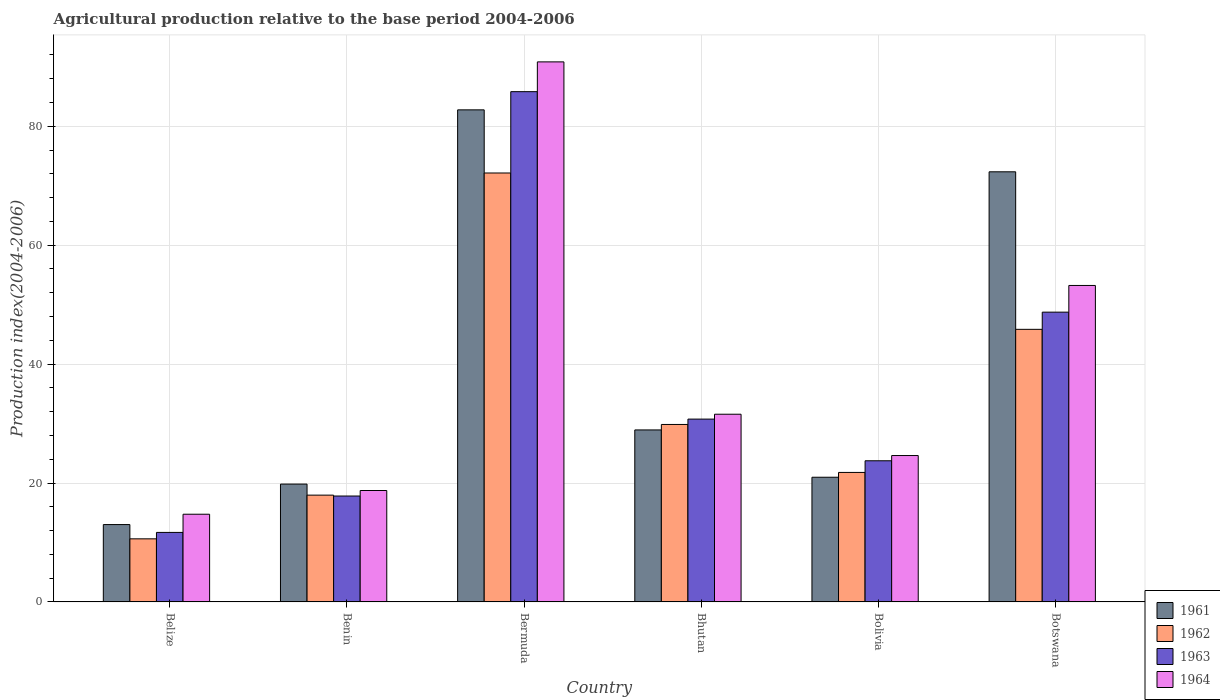Are the number of bars on each tick of the X-axis equal?
Provide a succinct answer. Yes. How many bars are there on the 6th tick from the left?
Give a very brief answer. 4. What is the label of the 2nd group of bars from the left?
Your response must be concise. Benin. What is the agricultural production index in 1963 in Belize?
Ensure brevity in your answer.  11.69. Across all countries, what is the maximum agricultural production index in 1962?
Your answer should be compact. 72.15. Across all countries, what is the minimum agricultural production index in 1964?
Provide a short and direct response. 14.75. In which country was the agricultural production index in 1962 maximum?
Give a very brief answer. Bermuda. In which country was the agricultural production index in 1963 minimum?
Give a very brief answer. Belize. What is the total agricultural production index in 1964 in the graph?
Give a very brief answer. 233.75. What is the difference between the agricultural production index in 1962 in Bermuda and that in Bhutan?
Offer a very short reply. 42.3. What is the difference between the agricultural production index in 1963 in Belize and the agricultural production index in 1961 in Botswana?
Ensure brevity in your answer.  -60.66. What is the average agricultural production index in 1962 per country?
Make the answer very short. 33.03. What is the difference between the agricultural production index of/in 1962 and agricultural production index of/in 1963 in Bermuda?
Your answer should be very brief. -13.68. In how many countries, is the agricultural production index in 1964 greater than 52?
Ensure brevity in your answer.  2. What is the ratio of the agricultural production index in 1963 in Benin to that in Bhutan?
Your answer should be compact. 0.58. Is the agricultural production index in 1962 in Benin less than that in Botswana?
Your answer should be compact. Yes. What is the difference between the highest and the second highest agricultural production index in 1961?
Give a very brief answer. -10.42. What is the difference between the highest and the lowest agricultural production index in 1961?
Offer a terse response. 69.76. In how many countries, is the agricultural production index in 1963 greater than the average agricultural production index in 1963 taken over all countries?
Ensure brevity in your answer.  2. Is it the case that in every country, the sum of the agricultural production index in 1962 and agricultural production index in 1964 is greater than the sum of agricultural production index in 1961 and agricultural production index in 1963?
Your answer should be compact. No. What does the 3rd bar from the left in Bolivia represents?
Make the answer very short. 1963. Are all the bars in the graph horizontal?
Provide a succinct answer. No. Does the graph contain any zero values?
Ensure brevity in your answer.  No. Where does the legend appear in the graph?
Offer a very short reply. Bottom right. How many legend labels are there?
Provide a short and direct response. 4. How are the legend labels stacked?
Your answer should be compact. Vertical. What is the title of the graph?
Make the answer very short. Agricultural production relative to the base period 2004-2006. Does "1989" appear as one of the legend labels in the graph?
Your answer should be compact. No. What is the label or title of the Y-axis?
Give a very brief answer. Production index(2004-2006). What is the Production index(2004-2006) of 1961 in Belize?
Your answer should be very brief. 13.01. What is the Production index(2004-2006) of 1962 in Belize?
Offer a terse response. 10.61. What is the Production index(2004-2006) in 1963 in Belize?
Ensure brevity in your answer.  11.69. What is the Production index(2004-2006) of 1964 in Belize?
Make the answer very short. 14.75. What is the Production index(2004-2006) of 1961 in Benin?
Give a very brief answer. 19.82. What is the Production index(2004-2006) of 1962 in Benin?
Offer a very short reply. 17.96. What is the Production index(2004-2006) of 1963 in Benin?
Make the answer very short. 17.81. What is the Production index(2004-2006) of 1964 in Benin?
Your answer should be very brief. 18.74. What is the Production index(2004-2006) of 1961 in Bermuda?
Provide a succinct answer. 82.77. What is the Production index(2004-2006) in 1962 in Bermuda?
Give a very brief answer. 72.15. What is the Production index(2004-2006) of 1963 in Bermuda?
Your answer should be compact. 85.83. What is the Production index(2004-2006) in 1964 in Bermuda?
Keep it short and to the point. 90.84. What is the Production index(2004-2006) of 1961 in Bhutan?
Provide a short and direct response. 28.93. What is the Production index(2004-2006) in 1962 in Bhutan?
Offer a terse response. 29.85. What is the Production index(2004-2006) of 1963 in Bhutan?
Offer a terse response. 30.75. What is the Production index(2004-2006) of 1964 in Bhutan?
Offer a terse response. 31.57. What is the Production index(2004-2006) of 1961 in Bolivia?
Keep it short and to the point. 20.97. What is the Production index(2004-2006) of 1962 in Bolivia?
Your answer should be compact. 21.78. What is the Production index(2004-2006) of 1963 in Bolivia?
Provide a succinct answer. 23.74. What is the Production index(2004-2006) of 1964 in Bolivia?
Ensure brevity in your answer.  24.62. What is the Production index(2004-2006) in 1961 in Botswana?
Provide a succinct answer. 72.35. What is the Production index(2004-2006) in 1962 in Botswana?
Offer a terse response. 45.85. What is the Production index(2004-2006) of 1963 in Botswana?
Your answer should be compact. 48.74. What is the Production index(2004-2006) of 1964 in Botswana?
Your answer should be very brief. 53.23. Across all countries, what is the maximum Production index(2004-2006) in 1961?
Ensure brevity in your answer.  82.77. Across all countries, what is the maximum Production index(2004-2006) in 1962?
Give a very brief answer. 72.15. Across all countries, what is the maximum Production index(2004-2006) of 1963?
Make the answer very short. 85.83. Across all countries, what is the maximum Production index(2004-2006) of 1964?
Give a very brief answer. 90.84. Across all countries, what is the minimum Production index(2004-2006) of 1961?
Your response must be concise. 13.01. Across all countries, what is the minimum Production index(2004-2006) of 1962?
Your answer should be compact. 10.61. Across all countries, what is the minimum Production index(2004-2006) of 1963?
Offer a terse response. 11.69. Across all countries, what is the minimum Production index(2004-2006) in 1964?
Provide a succinct answer. 14.75. What is the total Production index(2004-2006) in 1961 in the graph?
Offer a terse response. 237.85. What is the total Production index(2004-2006) of 1962 in the graph?
Your response must be concise. 198.2. What is the total Production index(2004-2006) in 1963 in the graph?
Give a very brief answer. 218.56. What is the total Production index(2004-2006) in 1964 in the graph?
Make the answer very short. 233.75. What is the difference between the Production index(2004-2006) of 1961 in Belize and that in Benin?
Ensure brevity in your answer.  -6.81. What is the difference between the Production index(2004-2006) in 1962 in Belize and that in Benin?
Ensure brevity in your answer.  -7.35. What is the difference between the Production index(2004-2006) in 1963 in Belize and that in Benin?
Give a very brief answer. -6.12. What is the difference between the Production index(2004-2006) in 1964 in Belize and that in Benin?
Offer a terse response. -3.99. What is the difference between the Production index(2004-2006) of 1961 in Belize and that in Bermuda?
Give a very brief answer. -69.76. What is the difference between the Production index(2004-2006) of 1962 in Belize and that in Bermuda?
Ensure brevity in your answer.  -61.54. What is the difference between the Production index(2004-2006) in 1963 in Belize and that in Bermuda?
Ensure brevity in your answer.  -74.14. What is the difference between the Production index(2004-2006) of 1964 in Belize and that in Bermuda?
Your answer should be very brief. -76.09. What is the difference between the Production index(2004-2006) in 1961 in Belize and that in Bhutan?
Your answer should be compact. -15.92. What is the difference between the Production index(2004-2006) of 1962 in Belize and that in Bhutan?
Give a very brief answer. -19.24. What is the difference between the Production index(2004-2006) of 1963 in Belize and that in Bhutan?
Provide a short and direct response. -19.06. What is the difference between the Production index(2004-2006) of 1964 in Belize and that in Bhutan?
Your response must be concise. -16.82. What is the difference between the Production index(2004-2006) of 1961 in Belize and that in Bolivia?
Keep it short and to the point. -7.96. What is the difference between the Production index(2004-2006) of 1962 in Belize and that in Bolivia?
Offer a terse response. -11.17. What is the difference between the Production index(2004-2006) in 1963 in Belize and that in Bolivia?
Ensure brevity in your answer.  -12.05. What is the difference between the Production index(2004-2006) in 1964 in Belize and that in Bolivia?
Your response must be concise. -9.87. What is the difference between the Production index(2004-2006) in 1961 in Belize and that in Botswana?
Offer a very short reply. -59.34. What is the difference between the Production index(2004-2006) of 1962 in Belize and that in Botswana?
Provide a succinct answer. -35.24. What is the difference between the Production index(2004-2006) of 1963 in Belize and that in Botswana?
Ensure brevity in your answer.  -37.05. What is the difference between the Production index(2004-2006) of 1964 in Belize and that in Botswana?
Provide a succinct answer. -38.48. What is the difference between the Production index(2004-2006) in 1961 in Benin and that in Bermuda?
Ensure brevity in your answer.  -62.95. What is the difference between the Production index(2004-2006) of 1962 in Benin and that in Bermuda?
Make the answer very short. -54.19. What is the difference between the Production index(2004-2006) of 1963 in Benin and that in Bermuda?
Give a very brief answer. -68.02. What is the difference between the Production index(2004-2006) in 1964 in Benin and that in Bermuda?
Your response must be concise. -72.1. What is the difference between the Production index(2004-2006) in 1961 in Benin and that in Bhutan?
Offer a terse response. -9.11. What is the difference between the Production index(2004-2006) in 1962 in Benin and that in Bhutan?
Ensure brevity in your answer.  -11.89. What is the difference between the Production index(2004-2006) in 1963 in Benin and that in Bhutan?
Ensure brevity in your answer.  -12.94. What is the difference between the Production index(2004-2006) in 1964 in Benin and that in Bhutan?
Provide a succinct answer. -12.83. What is the difference between the Production index(2004-2006) in 1961 in Benin and that in Bolivia?
Provide a succinct answer. -1.15. What is the difference between the Production index(2004-2006) in 1962 in Benin and that in Bolivia?
Provide a succinct answer. -3.82. What is the difference between the Production index(2004-2006) in 1963 in Benin and that in Bolivia?
Keep it short and to the point. -5.93. What is the difference between the Production index(2004-2006) of 1964 in Benin and that in Bolivia?
Offer a terse response. -5.88. What is the difference between the Production index(2004-2006) in 1961 in Benin and that in Botswana?
Make the answer very short. -52.53. What is the difference between the Production index(2004-2006) of 1962 in Benin and that in Botswana?
Your answer should be very brief. -27.89. What is the difference between the Production index(2004-2006) of 1963 in Benin and that in Botswana?
Provide a succinct answer. -30.93. What is the difference between the Production index(2004-2006) of 1964 in Benin and that in Botswana?
Offer a very short reply. -34.49. What is the difference between the Production index(2004-2006) of 1961 in Bermuda and that in Bhutan?
Offer a very short reply. 53.84. What is the difference between the Production index(2004-2006) of 1962 in Bermuda and that in Bhutan?
Your response must be concise. 42.3. What is the difference between the Production index(2004-2006) in 1963 in Bermuda and that in Bhutan?
Your response must be concise. 55.08. What is the difference between the Production index(2004-2006) in 1964 in Bermuda and that in Bhutan?
Ensure brevity in your answer.  59.27. What is the difference between the Production index(2004-2006) of 1961 in Bermuda and that in Bolivia?
Provide a succinct answer. 61.8. What is the difference between the Production index(2004-2006) of 1962 in Bermuda and that in Bolivia?
Provide a succinct answer. 50.37. What is the difference between the Production index(2004-2006) in 1963 in Bermuda and that in Bolivia?
Offer a terse response. 62.09. What is the difference between the Production index(2004-2006) of 1964 in Bermuda and that in Bolivia?
Provide a short and direct response. 66.22. What is the difference between the Production index(2004-2006) in 1961 in Bermuda and that in Botswana?
Your answer should be very brief. 10.42. What is the difference between the Production index(2004-2006) in 1962 in Bermuda and that in Botswana?
Your response must be concise. 26.3. What is the difference between the Production index(2004-2006) in 1963 in Bermuda and that in Botswana?
Offer a terse response. 37.09. What is the difference between the Production index(2004-2006) in 1964 in Bermuda and that in Botswana?
Offer a terse response. 37.61. What is the difference between the Production index(2004-2006) of 1961 in Bhutan and that in Bolivia?
Provide a short and direct response. 7.96. What is the difference between the Production index(2004-2006) in 1962 in Bhutan and that in Bolivia?
Ensure brevity in your answer.  8.07. What is the difference between the Production index(2004-2006) of 1963 in Bhutan and that in Bolivia?
Give a very brief answer. 7.01. What is the difference between the Production index(2004-2006) of 1964 in Bhutan and that in Bolivia?
Provide a short and direct response. 6.95. What is the difference between the Production index(2004-2006) of 1961 in Bhutan and that in Botswana?
Your response must be concise. -43.42. What is the difference between the Production index(2004-2006) in 1963 in Bhutan and that in Botswana?
Give a very brief answer. -17.99. What is the difference between the Production index(2004-2006) of 1964 in Bhutan and that in Botswana?
Your answer should be very brief. -21.66. What is the difference between the Production index(2004-2006) in 1961 in Bolivia and that in Botswana?
Your answer should be very brief. -51.38. What is the difference between the Production index(2004-2006) in 1962 in Bolivia and that in Botswana?
Make the answer very short. -24.07. What is the difference between the Production index(2004-2006) in 1963 in Bolivia and that in Botswana?
Keep it short and to the point. -25. What is the difference between the Production index(2004-2006) in 1964 in Bolivia and that in Botswana?
Make the answer very short. -28.61. What is the difference between the Production index(2004-2006) of 1961 in Belize and the Production index(2004-2006) of 1962 in Benin?
Your answer should be compact. -4.95. What is the difference between the Production index(2004-2006) of 1961 in Belize and the Production index(2004-2006) of 1963 in Benin?
Your answer should be compact. -4.8. What is the difference between the Production index(2004-2006) in 1961 in Belize and the Production index(2004-2006) in 1964 in Benin?
Your answer should be very brief. -5.73. What is the difference between the Production index(2004-2006) in 1962 in Belize and the Production index(2004-2006) in 1963 in Benin?
Your answer should be compact. -7.2. What is the difference between the Production index(2004-2006) in 1962 in Belize and the Production index(2004-2006) in 1964 in Benin?
Keep it short and to the point. -8.13. What is the difference between the Production index(2004-2006) of 1963 in Belize and the Production index(2004-2006) of 1964 in Benin?
Provide a short and direct response. -7.05. What is the difference between the Production index(2004-2006) in 1961 in Belize and the Production index(2004-2006) in 1962 in Bermuda?
Your response must be concise. -59.14. What is the difference between the Production index(2004-2006) of 1961 in Belize and the Production index(2004-2006) of 1963 in Bermuda?
Provide a short and direct response. -72.82. What is the difference between the Production index(2004-2006) of 1961 in Belize and the Production index(2004-2006) of 1964 in Bermuda?
Offer a very short reply. -77.83. What is the difference between the Production index(2004-2006) of 1962 in Belize and the Production index(2004-2006) of 1963 in Bermuda?
Give a very brief answer. -75.22. What is the difference between the Production index(2004-2006) in 1962 in Belize and the Production index(2004-2006) in 1964 in Bermuda?
Offer a very short reply. -80.23. What is the difference between the Production index(2004-2006) in 1963 in Belize and the Production index(2004-2006) in 1964 in Bermuda?
Your answer should be compact. -79.15. What is the difference between the Production index(2004-2006) of 1961 in Belize and the Production index(2004-2006) of 1962 in Bhutan?
Make the answer very short. -16.84. What is the difference between the Production index(2004-2006) in 1961 in Belize and the Production index(2004-2006) in 1963 in Bhutan?
Make the answer very short. -17.74. What is the difference between the Production index(2004-2006) of 1961 in Belize and the Production index(2004-2006) of 1964 in Bhutan?
Your response must be concise. -18.56. What is the difference between the Production index(2004-2006) in 1962 in Belize and the Production index(2004-2006) in 1963 in Bhutan?
Offer a terse response. -20.14. What is the difference between the Production index(2004-2006) in 1962 in Belize and the Production index(2004-2006) in 1964 in Bhutan?
Ensure brevity in your answer.  -20.96. What is the difference between the Production index(2004-2006) of 1963 in Belize and the Production index(2004-2006) of 1964 in Bhutan?
Your response must be concise. -19.88. What is the difference between the Production index(2004-2006) in 1961 in Belize and the Production index(2004-2006) in 1962 in Bolivia?
Offer a terse response. -8.77. What is the difference between the Production index(2004-2006) in 1961 in Belize and the Production index(2004-2006) in 1963 in Bolivia?
Make the answer very short. -10.73. What is the difference between the Production index(2004-2006) of 1961 in Belize and the Production index(2004-2006) of 1964 in Bolivia?
Give a very brief answer. -11.61. What is the difference between the Production index(2004-2006) in 1962 in Belize and the Production index(2004-2006) in 1963 in Bolivia?
Your answer should be very brief. -13.13. What is the difference between the Production index(2004-2006) of 1962 in Belize and the Production index(2004-2006) of 1964 in Bolivia?
Make the answer very short. -14.01. What is the difference between the Production index(2004-2006) in 1963 in Belize and the Production index(2004-2006) in 1964 in Bolivia?
Provide a short and direct response. -12.93. What is the difference between the Production index(2004-2006) of 1961 in Belize and the Production index(2004-2006) of 1962 in Botswana?
Ensure brevity in your answer.  -32.84. What is the difference between the Production index(2004-2006) of 1961 in Belize and the Production index(2004-2006) of 1963 in Botswana?
Ensure brevity in your answer.  -35.73. What is the difference between the Production index(2004-2006) in 1961 in Belize and the Production index(2004-2006) in 1964 in Botswana?
Offer a very short reply. -40.22. What is the difference between the Production index(2004-2006) of 1962 in Belize and the Production index(2004-2006) of 1963 in Botswana?
Keep it short and to the point. -38.13. What is the difference between the Production index(2004-2006) of 1962 in Belize and the Production index(2004-2006) of 1964 in Botswana?
Provide a succinct answer. -42.62. What is the difference between the Production index(2004-2006) of 1963 in Belize and the Production index(2004-2006) of 1964 in Botswana?
Keep it short and to the point. -41.54. What is the difference between the Production index(2004-2006) of 1961 in Benin and the Production index(2004-2006) of 1962 in Bermuda?
Keep it short and to the point. -52.33. What is the difference between the Production index(2004-2006) of 1961 in Benin and the Production index(2004-2006) of 1963 in Bermuda?
Keep it short and to the point. -66.01. What is the difference between the Production index(2004-2006) in 1961 in Benin and the Production index(2004-2006) in 1964 in Bermuda?
Offer a very short reply. -71.02. What is the difference between the Production index(2004-2006) of 1962 in Benin and the Production index(2004-2006) of 1963 in Bermuda?
Offer a very short reply. -67.87. What is the difference between the Production index(2004-2006) of 1962 in Benin and the Production index(2004-2006) of 1964 in Bermuda?
Provide a short and direct response. -72.88. What is the difference between the Production index(2004-2006) of 1963 in Benin and the Production index(2004-2006) of 1964 in Bermuda?
Keep it short and to the point. -73.03. What is the difference between the Production index(2004-2006) of 1961 in Benin and the Production index(2004-2006) of 1962 in Bhutan?
Ensure brevity in your answer.  -10.03. What is the difference between the Production index(2004-2006) of 1961 in Benin and the Production index(2004-2006) of 1963 in Bhutan?
Keep it short and to the point. -10.93. What is the difference between the Production index(2004-2006) of 1961 in Benin and the Production index(2004-2006) of 1964 in Bhutan?
Your answer should be compact. -11.75. What is the difference between the Production index(2004-2006) of 1962 in Benin and the Production index(2004-2006) of 1963 in Bhutan?
Give a very brief answer. -12.79. What is the difference between the Production index(2004-2006) of 1962 in Benin and the Production index(2004-2006) of 1964 in Bhutan?
Give a very brief answer. -13.61. What is the difference between the Production index(2004-2006) of 1963 in Benin and the Production index(2004-2006) of 1964 in Bhutan?
Provide a succinct answer. -13.76. What is the difference between the Production index(2004-2006) in 1961 in Benin and the Production index(2004-2006) in 1962 in Bolivia?
Your response must be concise. -1.96. What is the difference between the Production index(2004-2006) of 1961 in Benin and the Production index(2004-2006) of 1963 in Bolivia?
Provide a succinct answer. -3.92. What is the difference between the Production index(2004-2006) of 1961 in Benin and the Production index(2004-2006) of 1964 in Bolivia?
Provide a short and direct response. -4.8. What is the difference between the Production index(2004-2006) of 1962 in Benin and the Production index(2004-2006) of 1963 in Bolivia?
Provide a succinct answer. -5.78. What is the difference between the Production index(2004-2006) in 1962 in Benin and the Production index(2004-2006) in 1964 in Bolivia?
Provide a succinct answer. -6.66. What is the difference between the Production index(2004-2006) of 1963 in Benin and the Production index(2004-2006) of 1964 in Bolivia?
Make the answer very short. -6.81. What is the difference between the Production index(2004-2006) in 1961 in Benin and the Production index(2004-2006) in 1962 in Botswana?
Your answer should be very brief. -26.03. What is the difference between the Production index(2004-2006) in 1961 in Benin and the Production index(2004-2006) in 1963 in Botswana?
Make the answer very short. -28.92. What is the difference between the Production index(2004-2006) of 1961 in Benin and the Production index(2004-2006) of 1964 in Botswana?
Make the answer very short. -33.41. What is the difference between the Production index(2004-2006) in 1962 in Benin and the Production index(2004-2006) in 1963 in Botswana?
Give a very brief answer. -30.78. What is the difference between the Production index(2004-2006) of 1962 in Benin and the Production index(2004-2006) of 1964 in Botswana?
Provide a short and direct response. -35.27. What is the difference between the Production index(2004-2006) of 1963 in Benin and the Production index(2004-2006) of 1964 in Botswana?
Give a very brief answer. -35.42. What is the difference between the Production index(2004-2006) in 1961 in Bermuda and the Production index(2004-2006) in 1962 in Bhutan?
Your response must be concise. 52.92. What is the difference between the Production index(2004-2006) in 1961 in Bermuda and the Production index(2004-2006) in 1963 in Bhutan?
Your answer should be compact. 52.02. What is the difference between the Production index(2004-2006) in 1961 in Bermuda and the Production index(2004-2006) in 1964 in Bhutan?
Your answer should be compact. 51.2. What is the difference between the Production index(2004-2006) in 1962 in Bermuda and the Production index(2004-2006) in 1963 in Bhutan?
Your answer should be compact. 41.4. What is the difference between the Production index(2004-2006) of 1962 in Bermuda and the Production index(2004-2006) of 1964 in Bhutan?
Offer a very short reply. 40.58. What is the difference between the Production index(2004-2006) in 1963 in Bermuda and the Production index(2004-2006) in 1964 in Bhutan?
Keep it short and to the point. 54.26. What is the difference between the Production index(2004-2006) of 1961 in Bermuda and the Production index(2004-2006) of 1962 in Bolivia?
Make the answer very short. 60.99. What is the difference between the Production index(2004-2006) in 1961 in Bermuda and the Production index(2004-2006) in 1963 in Bolivia?
Give a very brief answer. 59.03. What is the difference between the Production index(2004-2006) of 1961 in Bermuda and the Production index(2004-2006) of 1964 in Bolivia?
Your answer should be compact. 58.15. What is the difference between the Production index(2004-2006) in 1962 in Bermuda and the Production index(2004-2006) in 1963 in Bolivia?
Give a very brief answer. 48.41. What is the difference between the Production index(2004-2006) of 1962 in Bermuda and the Production index(2004-2006) of 1964 in Bolivia?
Your response must be concise. 47.53. What is the difference between the Production index(2004-2006) of 1963 in Bermuda and the Production index(2004-2006) of 1964 in Bolivia?
Offer a very short reply. 61.21. What is the difference between the Production index(2004-2006) of 1961 in Bermuda and the Production index(2004-2006) of 1962 in Botswana?
Provide a short and direct response. 36.92. What is the difference between the Production index(2004-2006) in 1961 in Bermuda and the Production index(2004-2006) in 1963 in Botswana?
Your response must be concise. 34.03. What is the difference between the Production index(2004-2006) of 1961 in Bermuda and the Production index(2004-2006) of 1964 in Botswana?
Your answer should be very brief. 29.54. What is the difference between the Production index(2004-2006) in 1962 in Bermuda and the Production index(2004-2006) in 1963 in Botswana?
Provide a succinct answer. 23.41. What is the difference between the Production index(2004-2006) in 1962 in Bermuda and the Production index(2004-2006) in 1964 in Botswana?
Your answer should be compact. 18.92. What is the difference between the Production index(2004-2006) in 1963 in Bermuda and the Production index(2004-2006) in 1964 in Botswana?
Provide a short and direct response. 32.6. What is the difference between the Production index(2004-2006) in 1961 in Bhutan and the Production index(2004-2006) in 1962 in Bolivia?
Your answer should be compact. 7.15. What is the difference between the Production index(2004-2006) of 1961 in Bhutan and the Production index(2004-2006) of 1963 in Bolivia?
Offer a terse response. 5.19. What is the difference between the Production index(2004-2006) of 1961 in Bhutan and the Production index(2004-2006) of 1964 in Bolivia?
Keep it short and to the point. 4.31. What is the difference between the Production index(2004-2006) in 1962 in Bhutan and the Production index(2004-2006) in 1963 in Bolivia?
Make the answer very short. 6.11. What is the difference between the Production index(2004-2006) of 1962 in Bhutan and the Production index(2004-2006) of 1964 in Bolivia?
Your answer should be compact. 5.23. What is the difference between the Production index(2004-2006) of 1963 in Bhutan and the Production index(2004-2006) of 1964 in Bolivia?
Your answer should be very brief. 6.13. What is the difference between the Production index(2004-2006) of 1961 in Bhutan and the Production index(2004-2006) of 1962 in Botswana?
Give a very brief answer. -16.92. What is the difference between the Production index(2004-2006) in 1961 in Bhutan and the Production index(2004-2006) in 1963 in Botswana?
Provide a succinct answer. -19.81. What is the difference between the Production index(2004-2006) in 1961 in Bhutan and the Production index(2004-2006) in 1964 in Botswana?
Give a very brief answer. -24.3. What is the difference between the Production index(2004-2006) of 1962 in Bhutan and the Production index(2004-2006) of 1963 in Botswana?
Your answer should be compact. -18.89. What is the difference between the Production index(2004-2006) of 1962 in Bhutan and the Production index(2004-2006) of 1964 in Botswana?
Ensure brevity in your answer.  -23.38. What is the difference between the Production index(2004-2006) in 1963 in Bhutan and the Production index(2004-2006) in 1964 in Botswana?
Offer a terse response. -22.48. What is the difference between the Production index(2004-2006) in 1961 in Bolivia and the Production index(2004-2006) in 1962 in Botswana?
Your answer should be compact. -24.88. What is the difference between the Production index(2004-2006) of 1961 in Bolivia and the Production index(2004-2006) of 1963 in Botswana?
Make the answer very short. -27.77. What is the difference between the Production index(2004-2006) in 1961 in Bolivia and the Production index(2004-2006) in 1964 in Botswana?
Give a very brief answer. -32.26. What is the difference between the Production index(2004-2006) of 1962 in Bolivia and the Production index(2004-2006) of 1963 in Botswana?
Give a very brief answer. -26.96. What is the difference between the Production index(2004-2006) of 1962 in Bolivia and the Production index(2004-2006) of 1964 in Botswana?
Offer a terse response. -31.45. What is the difference between the Production index(2004-2006) in 1963 in Bolivia and the Production index(2004-2006) in 1964 in Botswana?
Give a very brief answer. -29.49. What is the average Production index(2004-2006) of 1961 per country?
Provide a succinct answer. 39.64. What is the average Production index(2004-2006) of 1962 per country?
Provide a short and direct response. 33.03. What is the average Production index(2004-2006) of 1963 per country?
Provide a short and direct response. 36.43. What is the average Production index(2004-2006) in 1964 per country?
Your answer should be compact. 38.96. What is the difference between the Production index(2004-2006) of 1961 and Production index(2004-2006) of 1963 in Belize?
Give a very brief answer. 1.32. What is the difference between the Production index(2004-2006) in 1961 and Production index(2004-2006) in 1964 in Belize?
Your response must be concise. -1.74. What is the difference between the Production index(2004-2006) of 1962 and Production index(2004-2006) of 1963 in Belize?
Your answer should be very brief. -1.08. What is the difference between the Production index(2004-2006) in 1962 and Production index(2004-2006) in 1964 in Belize?
Provide a succinct answer. -4.14. What is the difference between the Production index(2004-2006) of 1963 and Production index(2004-2006) of 1964 in Belize?
Provide a succinct answer. -3.06. What is the difference between the Production index(2004-2006) of 1961 and Production index(2004-2006) of 1962 in Benin?
Provide a succinct answer. 1.86. What is the difference between the Production index(2004-2006) of 1961 and Production index(2004-2006) of 1963 in Benin?
Keep it short and to the point. 2.01. What is the difference between the Production index(2004-2006) in 1961 and Production index(2004-2006) in 1964 in Benin?
Make the answer very short. 1.08. What is the difference between the Production index(2004-2006) in 1962 and Production index(2004-2006) in 1963 in Benin?
Your response must be concise. 0.15. What is the difference between the Production index(2004-2006) of 1962 and Production index(2004-2006) of 1964 in Benin?
Make the answer very short. -0.78. What is the difference between the Production index(2004-2006) in 1963 and Production index(2004-2006) in 1964 in Benin?
Your response must be concise. -0.93. What is the difference between the Production index(2004-2006) in 1961 and Production index(2004-2006) in 1962 in Bermuda?
Your response must be concise. 10.62. What is the difference between the Production index(2004-2006) in 1961 and Production index(2004-2006) in 1963 in Bermuda?
Give a very brief answer. -3.06. What is the difference between the Production index(2004-2006) in 1961 and Production index(2004-2006) in 1964 in Bermuda?
Provide a short and direct response. -8.07. What is the difference between the Production index(2004-2006) in 1962 and Production index(2004-2006) in 1963 in Bermuda?
Provide a short and direct response. -13.68. What is the difference between the Production index(2004-2006) in 1962 and Production index(2004-2006) in 1964 in Bermuda?
Keep it short and to the point. -18.69. What is the difference between the Production index(2004-2006) of 1963 and Production index(2004-2006) of 1964 in Bermuda?
Your response must be concise. -5.01. What is the difference between the Production index(2004-2006) in 1961 and Production index(2004-2006) in 1962 in Bhutan?
Provide a short and direct response. -0.92. What is the difference between the Production index(2004-2006) of 1961 and Production index(2004-2006) of 1963 in Bhutan?
Make the answer very short. -1.82. What is the difference between the Production index(2004-2006) of 1961 and Production index(2004-2006) of 1964 in Bhutan?
Provide a short and direct response. -2.64. What is the difference between the Production index(2004-2006) in 1962 and Production index(2004-2006) in 1963 in Bhutan?
Your response must be concise. -0.9. What is the difference between the Production index(2004-2006) of 1962 and Production index(2004-2006) of 1964 in Bhutan?
Ensure brevity in your answer.  -1.72. What is the difference between the Production index(2004-2006) of 1963 and Production index(2004-2006) of 1964 in Bhutan?
Offer a terse response. -0.82. What is the difference between the Production index(2004-2006) in 1961 and Production index(2004-2006) in 1962 in Bolivia?
Keep it short and to the point. -0.81. What is the difference between the Production index(2004-2006) in 1961 and Production index(2004-2006) in 1963 in Bolivia?
Provide a succinct answer. -2.77. What is the difference between the Production index(2004-2006) of 1961 and Production index(2004-2006) of 1964 in Bolivia?
Your response must be concise. -3.65. What is the difference between the Production index(2004-2006) in 1962 and Production index(2004-2006) in 1963 in Bolivia?
Offer a terse response. -1.96. What is the difference between the Production index(2004-2006) of 1962 and Production index(2004-2006) of 1964 in Bolivia?
Keep it short and to the point. -2.84. What is the difference between the Production index(2004-2006) in 1963 and Production index(2004-2006) in 1964 in Bolivia?
Provide a short and direct response. -0.88. What is the difference between the Production index(2004-2006) of 1961 and Production index(2004-2006) of 1963 in Botswana?
Make the answer very short. 23.61. What is the difference between the Production index(2004-2006) of 1961 and Production index(2004-2006) of 1964 in Botswana?
Give a very brief answer. 19.12. What is the difference between the Production index(2004-2006) in 1962 and Production index(2004-2006) in 1963 in Botswana?
Your response must be concise. -2.89. What is the difference between the Production index(2004-2006) in 1962 and Production index(2004-2006) in 1964 in Botswana?
Offer a terse response. -7.38. What is the difference between the Production index(2004-2006) in 1963 and Production index(2004-2006) in 1964 in Botswana?
Your response must be concise. -4.49. What is the ratio of the Production index(2004-2006) in 1961 in Belize to that in Benin?
Your answer should be compact. 0.66. What is the ratio of the Production index(2004-2006) in 1962 in Belize to that in Benin?
Make the answer very short. 0.59. What is the ratio of the Production index(2004-2006) of 1963 in Belize to that in Benin?
Your answer should be compact. 0.66. What is the ratio of the Production index(2004-2006) of 1964 in Belize to that in Benin?
Ensure brevity in your answer.  0.79. What is the ratio of the Production index(2004-2006) in 1961 in Belize to that in Bermuda?
Your response must be concise. 0.16. What is the ratio of the Production index(2004-2006) of 1962 in Belize to that in Bermuda?
Provide a short and direct response. 0.15. What is the ratio of the Production index(2004-2006) in 1963 in Belize to that in Bermuda?
Provide a short and direct response. 0.14. What is the ratio of the Production index(2004-2006) of 1964 in Belize to that in Bermuda?
Give a very brief answer. 0.16. What is the ratio of the Production index(2004-2006) in 1961 in Belize to that in Bhutan?
Ensure brevity in your answer.  0.45. What is the ratio of the Production index(2004-2006) in 1962 in Belize to that in Bhutan?
Provide a short and direct response. 0.36. What is the ratio of the Production index(2004-2006) of 1963 in Belize to that in Bhutan?
Provide a succinct answer. 0.38. What is the ratio of the Production index(2004-2006) in 1964 in Belize to that in Bhutan?
Provide a short and direct response. 0.47. What is the ratio of the Production index(2004-2006) of 1961 in Belize to that in Bolivia?
Offer a very short reply. 0.62. What is the ratio of the Production index(2004-2006) in 1962 in Belize to that in Bolivia?
Keep it short and to the point. 0.49. What is the ratio of the Production index(2004-2006) of 1963 in Belize to that in Bolivia?
Offer a very short reply. 0.49. What is the ratio of the Production index(2004-2006) in 1964 in Belize to that in Bolivia?
Provide a succinct answer. 0.6. What is the ratio of the Production index(2004-2006) in 1961 in Belize to that in Botswana?
Ensure brevity in your answer.  0.18. What is the ratio of the Production index(2004-2006) in 1962 in Belize to that in Botswana?
Your answer should be compact. 0.23. What is the ratio of the Production index(2004-2006) in 1963 in Belize to that in Botswana?
Your response must be concise. 0.24. What is the ratio of the Production index(2004-2006) of 1964 in Belize to that in Botswana?
Make the answer very short. 0.28. What is the ratio of the Production index(2004-2006) of 1961 in Benin to that in Bermuda?
Offer a terse response. 0.24. What is the ratio of the Production index(2004-2006) in 1962 in Benin to that in Bermuda?
Your response must be concise. 0.25. What is the ratio of the Production index(2004-2006) of 1963 in Benin to that in Bermuda?
Offer a very short reply. 0.21. What is the ratio of the Production index(2004-2006) in 1964 in Benin to that in Bermuda?
Keep it short and to the point. 0.21. What is the ratio of the Production index(2004-2006) of 1961 in Benin to that in Bhutan?
Ensure brevity in your answer.  0.69. What is the ratio of the Production index(2004-2006) in 1962 in Benin to that in Bhutan?
Provide a short and direct response. 0.6. What is the ratio of the Production index(2004-2006) in 1963 in Benin to that in Bhutan?
Give a very brief answer. 0.58. What is the ratio of the Production index(2004-2006) in 1964 in Benin to that in Bhutan?
Offer a terse response. 0.59. What is the ratio of the Production index(2004-2006) of 1961 in Benin to that in Bolivia?
Ensure brevity in your answer.  0.95. What is the ratio of the Production index(2004-2006) in 1962 in Benin to that in Bolivia?
Make the answer very short. 0.82. What is the ratio of the Production index(2004-2006) of 1963 in Benin to that in Bolivia?
Keep it short and to the point. 0.75. What is the ratio of the Production index(2004-2006) of 1964 in Benin to that in Bolivia?
Provide a short and direct response. 0.76. What is the ratio of the Production index(2004-2006) in 1961 in Benin to that in Botswana?
Provide a succinct answer. 0.27. What is the ratio of the Production index(2004-2006) of 1962 in Benin to that in Botswana?
Ensure brevity in your answer.  0.39. What is the ratio of the Production index(2004-2006) of 1963 in Benin to that in Botswana?
Your answer should be compact. 0.37. What is the ratio of the Production index(2004-2006) in 1964 in Benin to that in Botswana?
Provide a succinct answer. 0.35. What is the ratio of the Production index(2004-2006) in 1961 in Bermuda to that in Bhutan?
Provide a succinct answer. 2.86. What is the ratio of the Production index(2004-2006) of 1962 in Bermuda to that in Bhutan?
Keep it short and to the point. 2.42. What is the ratio of the Production index(2004-2006) of 1963 in Bermuda to that in Bhutan?
Your answer should be compact. 2.79. What is the ratio of the Production index(2004-2006) of 1964 in Bermuda to that in Bhutan?
Provide a succinct answer. 2.88. What is the ratio of the Production index(2004-2006) in 1961 in Bermuda to that in Bolivia?
Provide a short and direct response. 3.95. What is the ratio of the Production index(2004-2006) of 1962 in Bermuda to that in Bolivia?
Offer a very short reply. 3.31. What is the ratio of the Production index(2004-2006) of 1963 in Bermuda to that in Bolivia?
Offer a very short reply. 3.62. What is the ratio of the Production index(2004-2006) in 1964 in Bermuda to that in Bolivia?
Make the answer very short. 3.69. What is the ratio of the Production index(2004-2006) in 1961 in Bermuda to that in Botswana?
Ensure brevity in your answer.  1.14. What is the ratio of the Production index(2004-2006) of 1962 in Bermuda to that in Botswana?
Offer a very short reply. 1.57. What is the ratio of the Production index(2004-2006) in 1963 in Bermuda to that in Botswana?
Provide a succinct answer. 1.76. What is the ratio of the Production index(2004-2006) of 1964 in Bermuda to that in Botswana?
Keep it short and to the point. 1.71. What is the ratio of the Production index(2004-2006) in 1961 in Bhutan to that in Bolivia?
Make the answer very short. 1.38. What is the ratio of the Production index(2004-2006) of 1962 in Bhutan to that in Bolivia?
Offer a very short reply. 1.37. What is the ratio of the Production index(2004-2006) in 1963 in Bhutan to that in Bolivia?
Your answer should be compact. 1.3. What is the ratio of the Production index(2004-2006) in 1964 in Bhutan to that in Bolivia?
Provide a short and direct response. 1.28. What is the ratio of the Production index(2004-2006) of 1961 in Bhutan to that in Botswana?
Make the answer very short. 0.4. What is the ratio of the Production index(2004-2006) of 1962 in Bhutan to that in Botswana?
Your answer should be compact. 0.65. What is the ratio of the Production index(2004-2006) of 1963 in Bhutan to that in Botswana?
Offer a terse response. 0.63. What is the ratio of the Production index(2004-2006) of 1964 in Bhutan to that in Botswana?
Your answer should be very brief. 0.59. What is the ratio of the Production index(2004-2006) of 1961 in Bolivia to that in Botswana?
Offer a very short reply. 0.29. What is the ratio of the Production index(2004-2006) in 1962 in Bolivia to that in Botswana?
Make the answer very short. 0.47. What is the ratio of the Production index(2004-2006) in 1963 in Bolivia to that in Botswana?
Your answer should be compact. 0.49. What is the ratio of the Production index(2004-2006) in 1964 in Bolivia to that in Botswana?
Keep it short and to the point. 0.46. What is the difference between the highest and the second highest Production index(2004-2006) in 1961?
Keep it short and to the point. 10.42. What is the difference between the highest and the second highest Production index(2004-2006) of 1962?
Offer a very short reply. 26.3. What is the difference between the highest and the second highest Production index(2004-2006) of 1963?
Your answer should be compact. 37.09. What is the difference between the highest and the second highest Production index(2004-2006) of 1964?
Offer a terse response. 37.61. What is the difference between the highest and the lowest Production index(2004-2006) of 1961?
Keep it short and to the point. 69.76. What is the difference between the highest and the lowest Production index(2004-2006) of 1962?
Provide a succinct answer. 61.54. What is the difference between the highest and the lowest Production index(2004-2006) of 1963?
Give a very brief answer. 74.14. What is the difference between the highest and the lowest Production index(2004-2006) of 1964?
Keep it short and to the point. 76.09. 